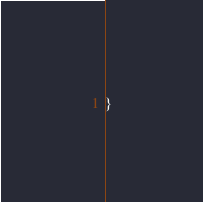Convert code to text. <code><loc_0><loc_0><loc_500><loc_500><_Java_>}
</code> 